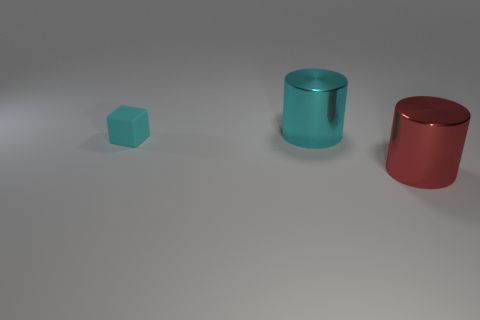Add 1 cyan cubes. How many objects exist? 4 Subtract all cubes. How many objects are left? 2 Add 2 cyan shiny cylinders. How many cyan shiny cylinders exist? 3 Subtract 1 cyan cylinders. How many objects are left? 2 Subtract all red cylinders. Subtract all big red cylinders. How many objects are left? 1 Add 1 big red shiny objects. How many big red shiny objects are left? 2 